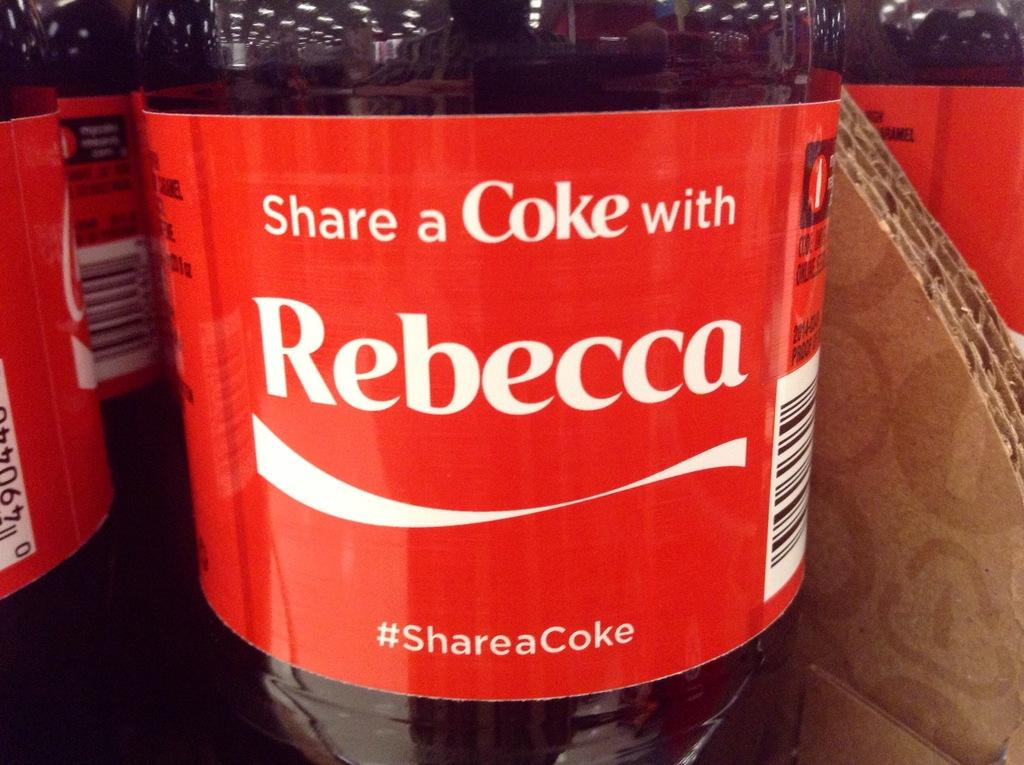<image>
Relay a brief, clear account of the picture shown. A Coke label invites us to share a coke with Rebecca. 